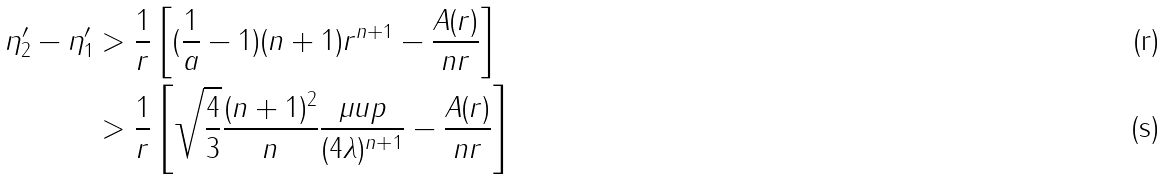Convert formula to latex. <formula><loc_0><loc_0><loc_500><loc_500>\eta _ { 2 } ^ { \prime } - \eta _ { 1 } ^ { \prime } & > \frac { 1 } { r } \left [ ( \frac { 1 } { a } - 1 ) ( n + 1 ) r ^ { n + 1 } - \frac { A ( r ) } { n r } \right ] \\ & > \frac { 1 } { r } \left [ \sqrt { \frac { 4 } { 3 } } \frac { ( n + 1 ) ^ { 2 } } { n } \frac { \mu u p } { ( 4 \lambda ) ^ { n + 1 } } - \frac { A ( r ) } { n r } \right ]</formula> 